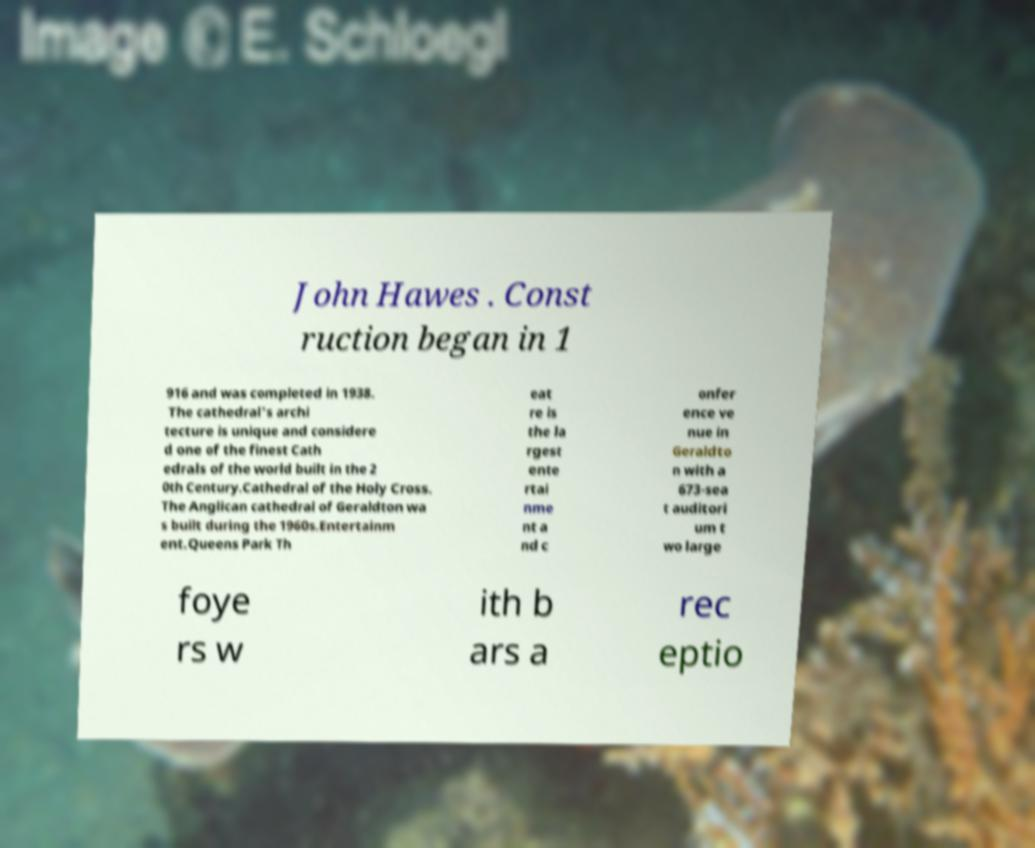There's text embedded in this image that I need extracted. Can you transcribe it verbatim? John Hawes . Const ruction began in 1 916 and was completed in 1938. The cathedral's archi tecture is unique and considere d one of the finest Cath edrals of the world built in the 2 0th Century.Cathedral of the Holy Cross. The Anglican cathedral of Geraldton wa s built during the 1960s.Entertainm ent.Queens Park Th eat re is the la rgest ente rtai nme nt a nd c onfer ence ve nue in Geraldto n with a 673-sea t auditori um t wo large foye rs w ith b ars a rec eptio 